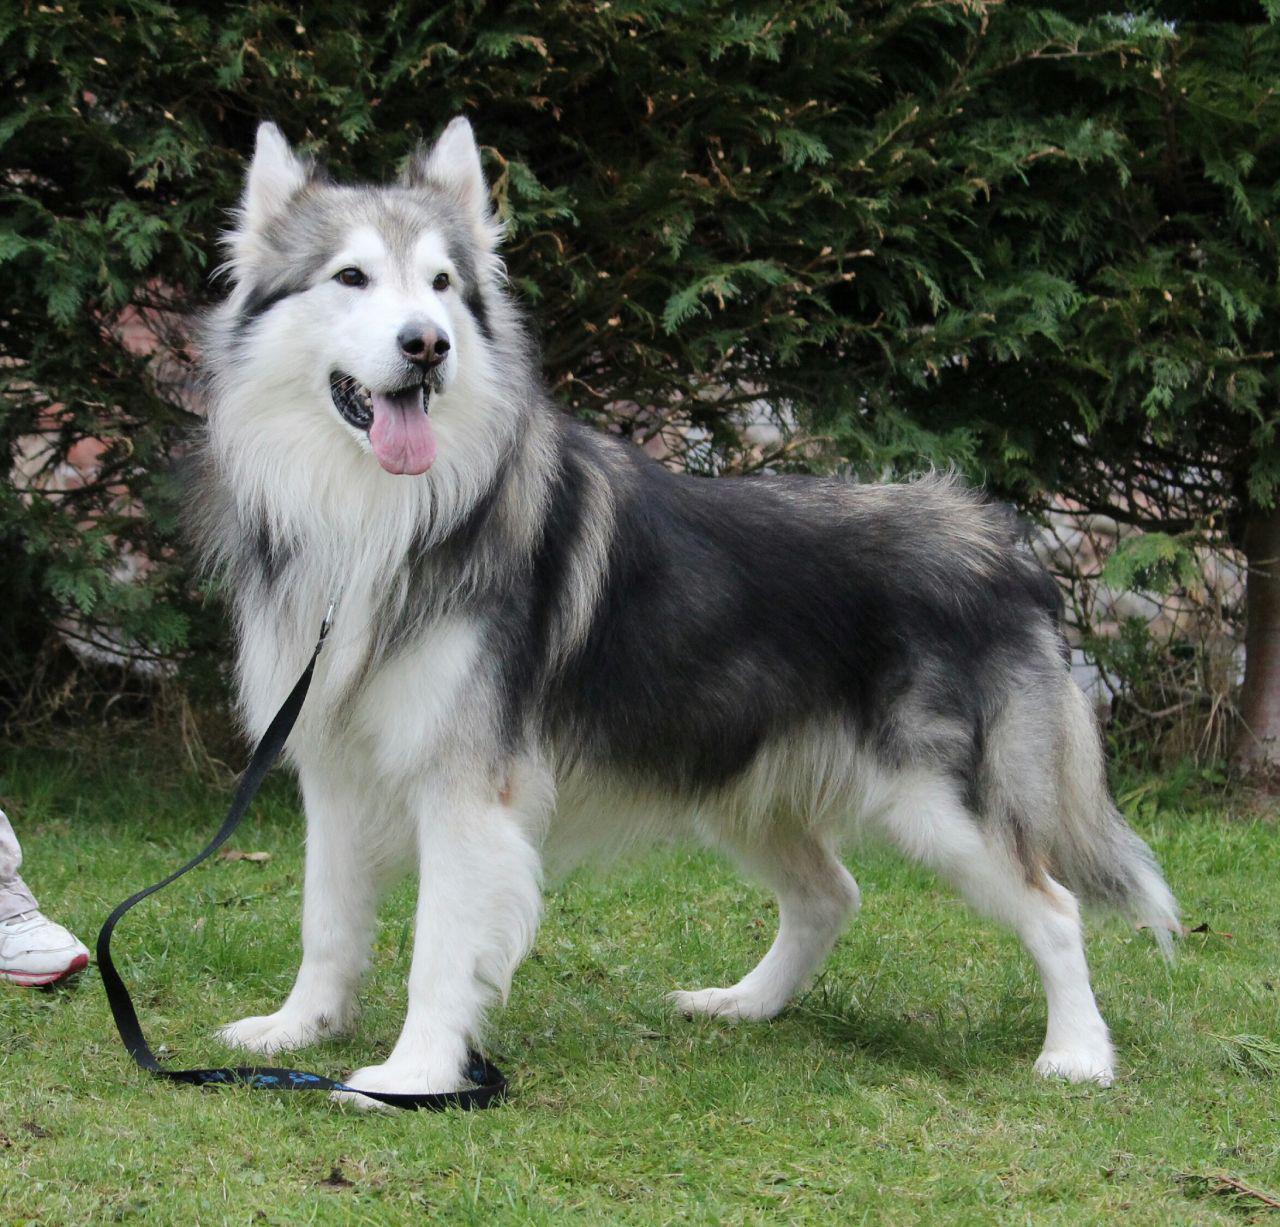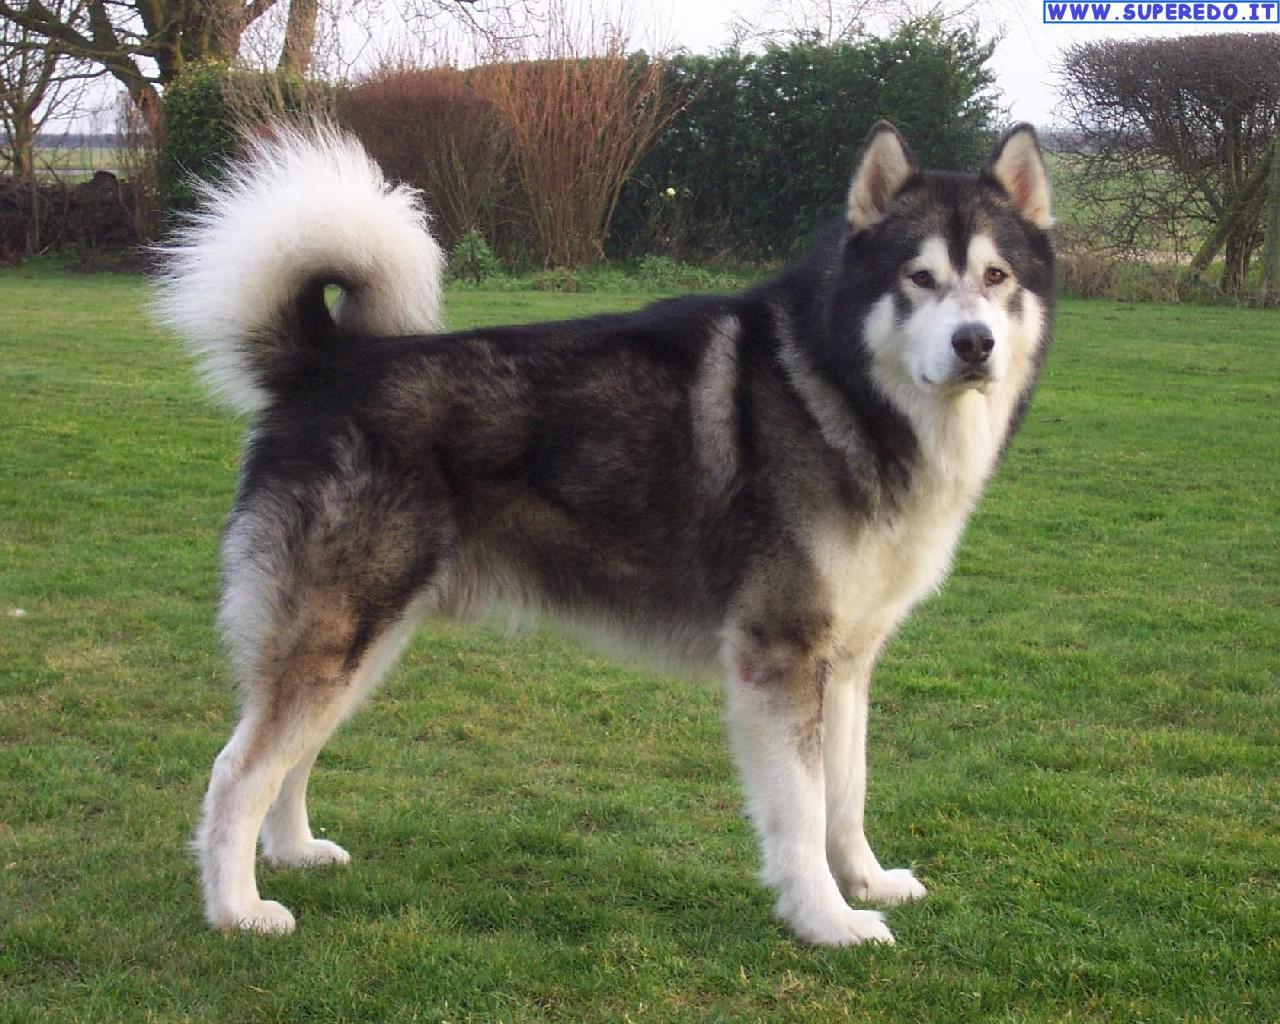The first image is the image on the left, the second image is the image on the right. Considering the images on both sides, is "Both dogs have their mouths open." valid? Answer yes or no. No. The first image is the image on the left, the second image is the image on the right. For the images displayed, is the sentence "There are two dogs with their mouths open." factually correct? Answer yes or no. No. 